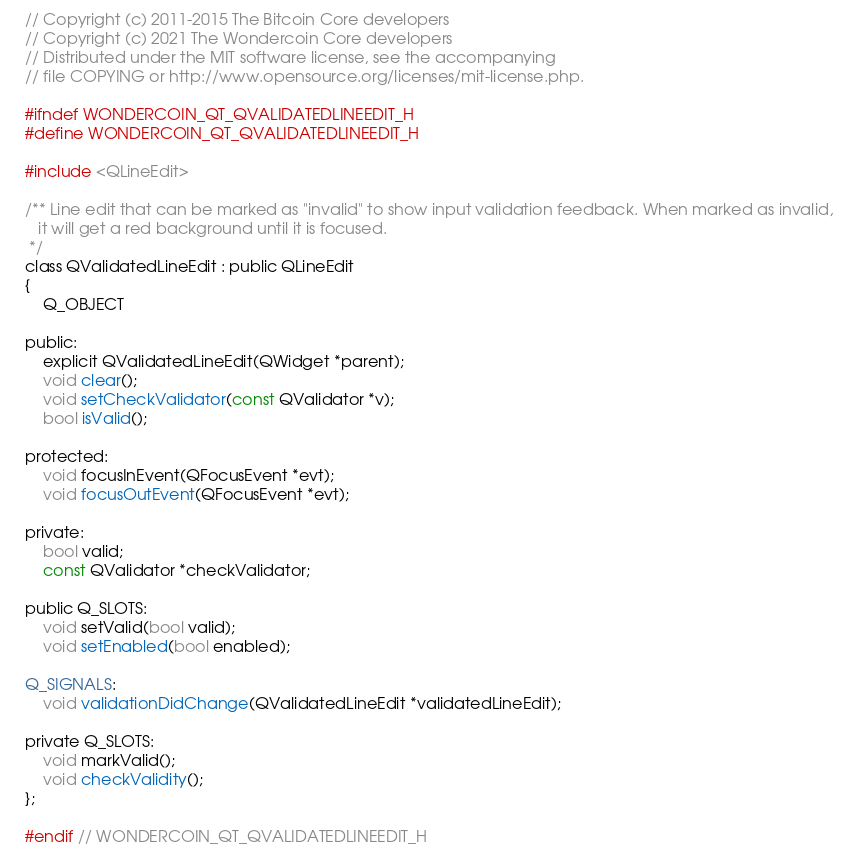<code> <loc_0><loc_0><loc_500><loc_500><_C_>// Copyright (c) 2011-2015 The Bitcoin Core developers
// Copyright (c) 2021 The Wondercoin Core developers
// Distributed under the MIT software license, see the accompanying
// file COPYING or http://www.opensource.org/licenses/mit-license.php.

#ifndef WONDERCOIN_QT_QVALIDATEDLINEEDIT_H
#define WONDERCOIN_QT_QVALIDATEDLINEEDIT_H

#include <QLineEdit>

/** Line edit that can be marked as "invalid" to show input validation feedback. When marked as invalid,
   it will get a red background until it is focused.
 */
class QValidatedLineEdit : public QLineEdit
{
    Q_OBJECT

public:
    explicit QValidatedLineEdit(QWidget *parent);
    void clear();
    void setCheckValidator(const QValidator *v);
    bool isValid();

protected:
    void focusInEvent(QFocusEvent *evt);
    void focusOutEvent(QFocusEvent *evt);

private:
    bool valid;
    const QValidator *checkValidator;

public Q_SLOTS:
    void setValid(bool valid);
    void setEnabled(bool enabled);

Q_SIGNALS:
    void validationDidChange(QValidatedLineEdit *validatedLineEdit);
    
private Q_SLOTS:
    void markValid();
    void checkValidity();
};

#endif // WONDERCOIN_QT_QVALIDATEDLINEEDIT_H
</code> 